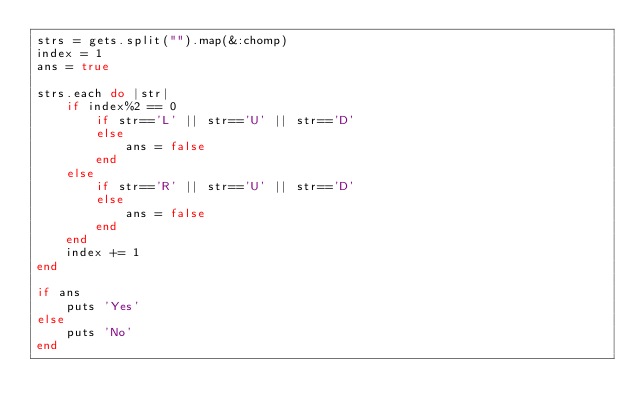Convert code to text. <code><loc_0><loc_0><loc_500><loc_500><_Ruby_>strs = gets.split("").map(&:chomp)
index = 1
ans = true

strs.each do |str|
    if index%2 == 0
        if str=='L' || str=='U' || str=='D'
        else
            ans = false
        end
    else
        if str=='R' || str=='U' || str=='D'
        else
            ans = false
        end
    end
    index += 1
end

if ans
    puts 'Yes'
else
    puts 'No'
end</code> 